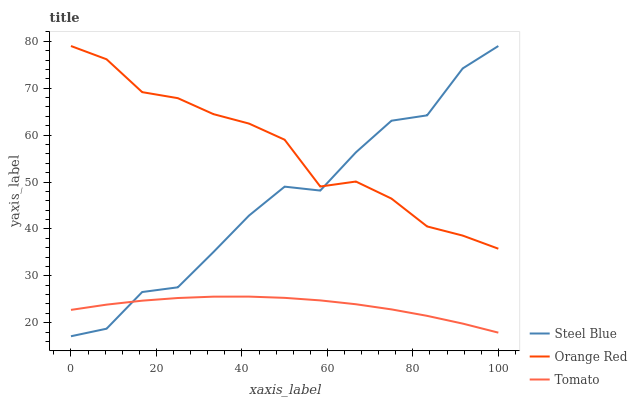Does Steel Blue have the minimum area under the curve?
Answer yes or no. No. Does Steel Blue have the maximum area under the curve?
Answer yes or no. No. Is Orange Red the smoothest?
Answer yes or no. No. Is Orange Red the roughest?
Answer yes or no. No. Does Orange Red have the lowest value?
Answer yes or no. No. Is Tomato less than Orange Red?
Answer yes or no. Yes. Is Orange Red greater than Tomato?
Answer yes or no. Yes. Does Tomato intersect Orange Red?
Answer yes or no. No. 